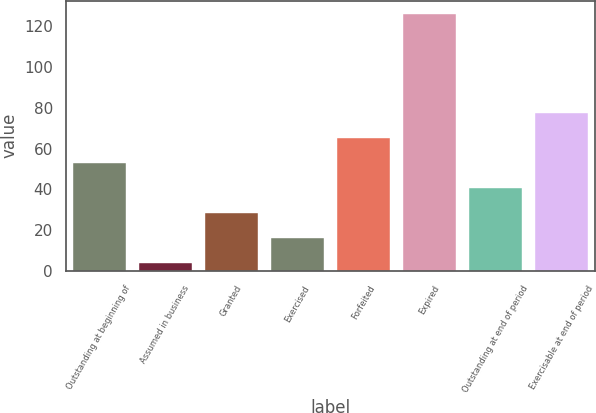Convert chart to OTSL. <chart><loc_0><loc_0><loc_500><loc_500><bar_chart><fcel>Outstanding at beginning of<fcel>Assumed in business<fcel>Granted<fcel>Exercised<fcel>Forfeited<fcel>Expired<fcel>Outstanding at end of period<fcel>Exercisable at end of period<nl><fcel>52.75<fcel>3.71<fcel>28.23<fcel>15.97<fcel>65.01<fcel>126.32<fcel>40.49<fcel>77.27<nl></chart> 